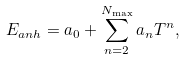<formula> <loc_0><loc_0><loc_500><loc_500>E _ { a n h } = a _ { 0 } + \sum _ { n = 2 } ^ { N _ { \max } } a _ { n } T ^ { n } ,</formula> 